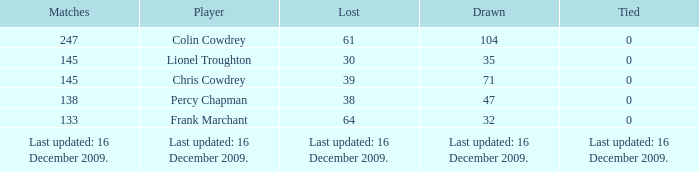What is the list with a tie of 0 and 47 draws? 38.0. 